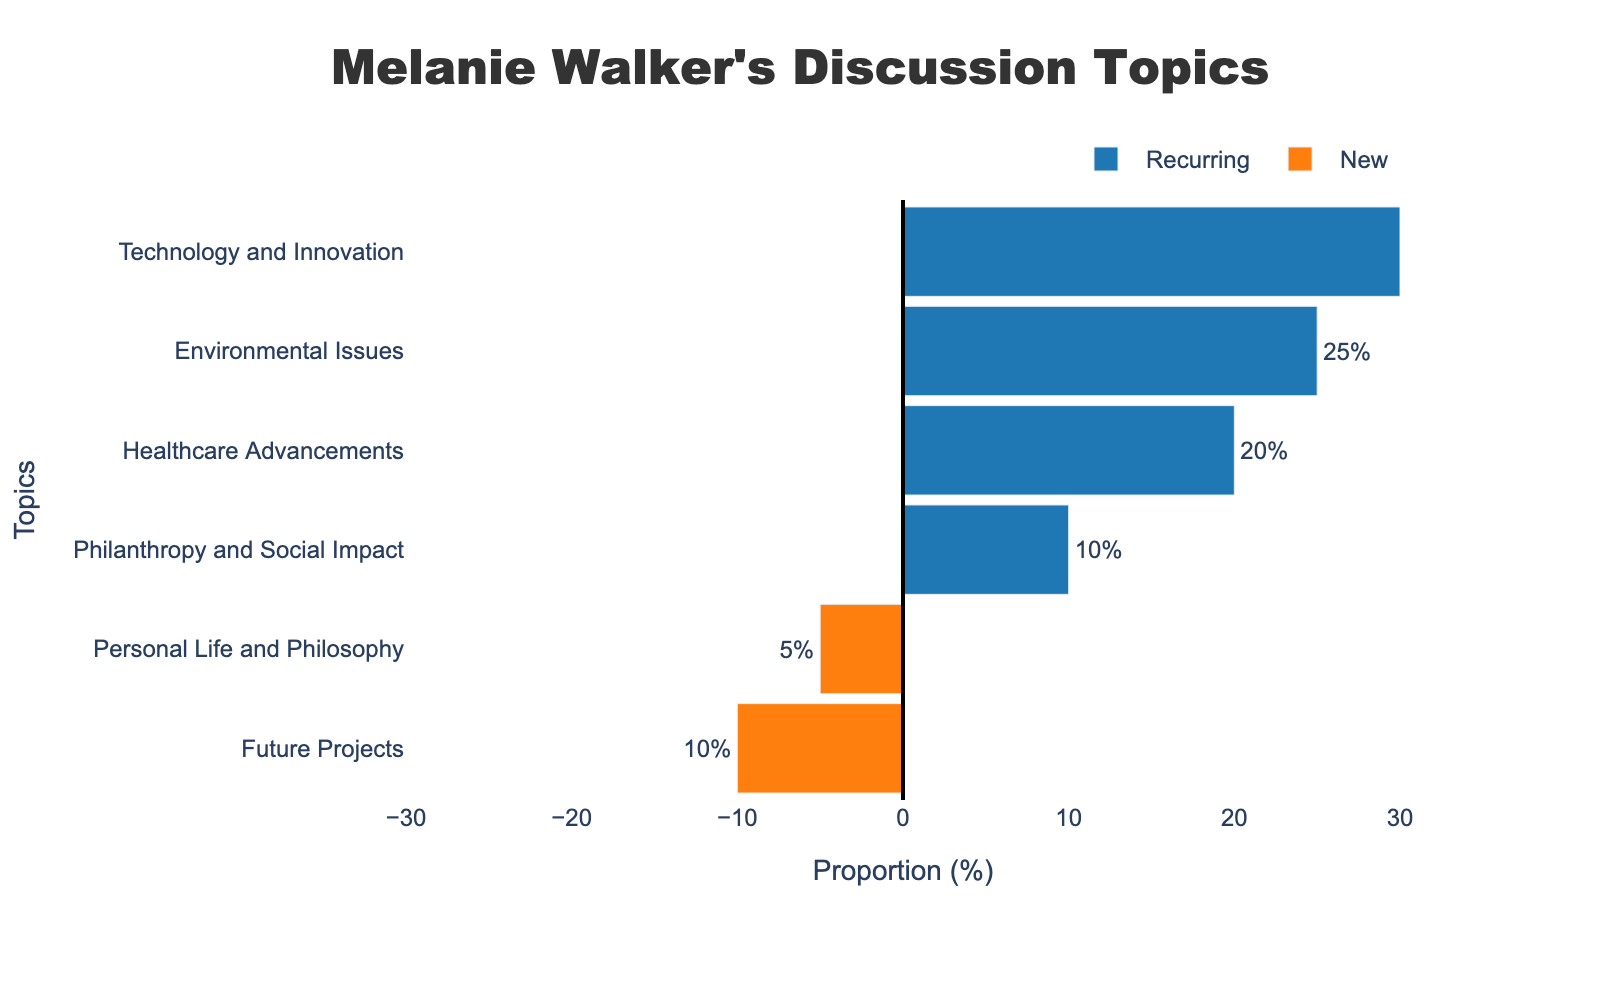What's the most frequently discussed topic? The bar representing "Technology and Innovation" is the longest among the recurring topics and has a proportion of 30%.
Answer: Technology and Innovation Which category (Recurring or New) has the greater total proportion of topics? Summing the proportions of recurring topics: 30% + 25% + 20% + 10% = 85%. Summing the proportions of new topics: 5% + 10% = 15%. The recurring category has a total proportion of 85%, which is greater than the 15% of new topics.
Answer: Recurring What is the difference in proportion between the most and least frequently discussed topics? The most frequently discussed topic is "Technology and Innovation" with 30%. The least frequently discussed topic is "Personal Life and Philosophy" with 5%. The difference is 30% - 5% = 25%.
Answer: 25% What proportion of Melanie Walker’s discussions are on new topics? Adding the proportions of the new topics: 5% (Personal Life and Philosophy) + 10% (Future Projects) = 15%.
Answer: 15% How much more frequently does Melanie Walker discuss "Healthcare Advancements" compared to "Future Projects"? The proportion for "Healthcare Advancements" is 20%, and for "Future Projects" it is 10%. The difference is 20% - 10% = 10%.
Answer: 10% Do recurring topics occupy more than half of the total discussion time? Total proportion for recurring topics is 85%. Since the total proportion for all topics is 100%, 85% is more than half.
Answer: Yes Which topic has the smallest proportion within the recurring category? Among the recurring topics, "Philanthropy and Social Impact" has the smallest proportion with 10%.
Answer: Philanthropy and Social Impact Compare the proportions of "Environmental Issues" and "Future Projects." Which is higher and by how much? "Environmental Issues" has a proportion of 25% and "Future Projects" has 10%. The difference is 25% - 10% = 15%. "Environmental Issues" is higher by 15%.
Answer: Environmental Issues by 15% If Melanie Walker's recurring topics are reduced by 10% for each, what would be the new proportion for "Technology and Innovation"? Initial proportion of "Technology and Innovation" is 30%. Reducing it by 10% of 30%, which is 3%, gives 30% - 3% = 27%.
Answer: 27% What is the sum proportion of the topics categorized as recurring? The sum of proportions for recurring topics is 30% (Technology and Innovation) + 25% (Environmental Issues) + 20% (Healthcare Advancements) + 10% (Philanthropy and Social Impact) = 85%.
Answer: 85% 